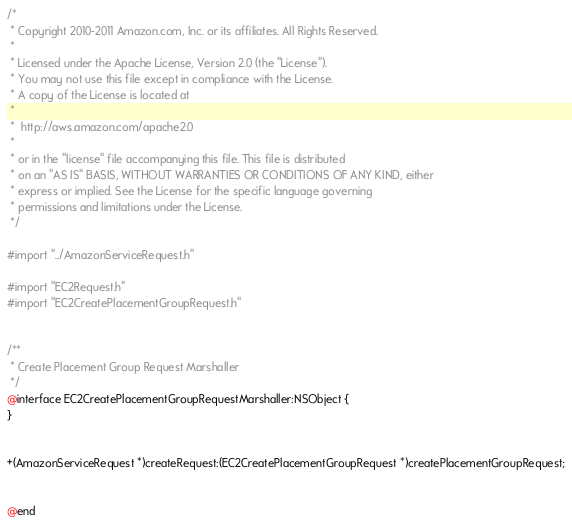Convert code to text. <code><loc_0><loc_0><loc_500><loc_500><_C_>/*
 * Copyright 2010-2011 Amazon.com, Inc. or its affiliates. All Rights Reserved.
 *
 * Licensed under the Apache License, Version 2.0 (the "License").
 * You may not use this file except in compliance with the License.
 * A copy of the License is located at
 *
 *  http://aws.amazon.com/apache2.0
 *
 * or in the "license" file accompanying this file. This file is distributed
 * on an "AS IS" BASIS, WITHOUT WARRANTIES OR CONDITIONS OF ANY KIND, either
 * express or implied. See the License for the specific language governing
 * permissions and limitations under the License.
 */

#import "../AmazonServiceRequest.h"

#import "EC2Request.h"
#import "EC2CreatePlacementGroupRequest.h"


/**
 * Create Placement Group Request Marshaller
 */
@interface EC2CreatePlacementGroupRequestMarshaller:NSObject {
}


+(AmazonServiceRequest *)createRequest:(EC2CreatePlacementGroupRequest *)createPlacementGroupRequest;


@end

</code> 